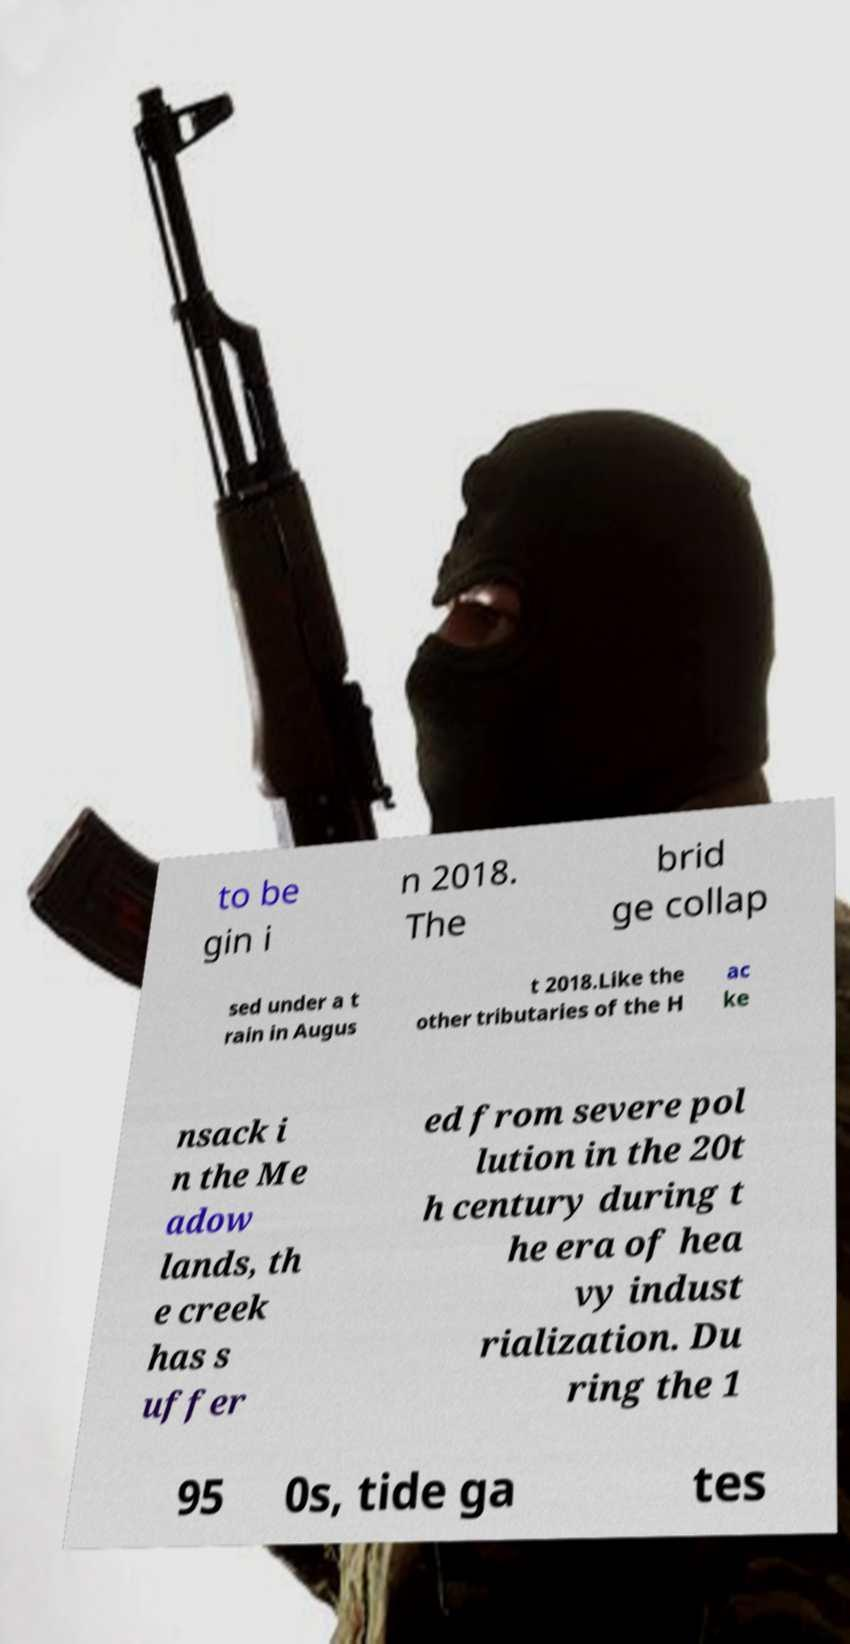Please identify and transcribe the text found in this image. to be gin i n 2018. The brid ge collap sed under a t rain in Augus t 2018.Like the other tributaries of the H ac ke nsack i n the Me adow lands, th e creek has s uffer ed from severe pol lution in the 20t h century during t he era of hea vy indust rialization. Du ring the 1 95 0s, tide ga tes 